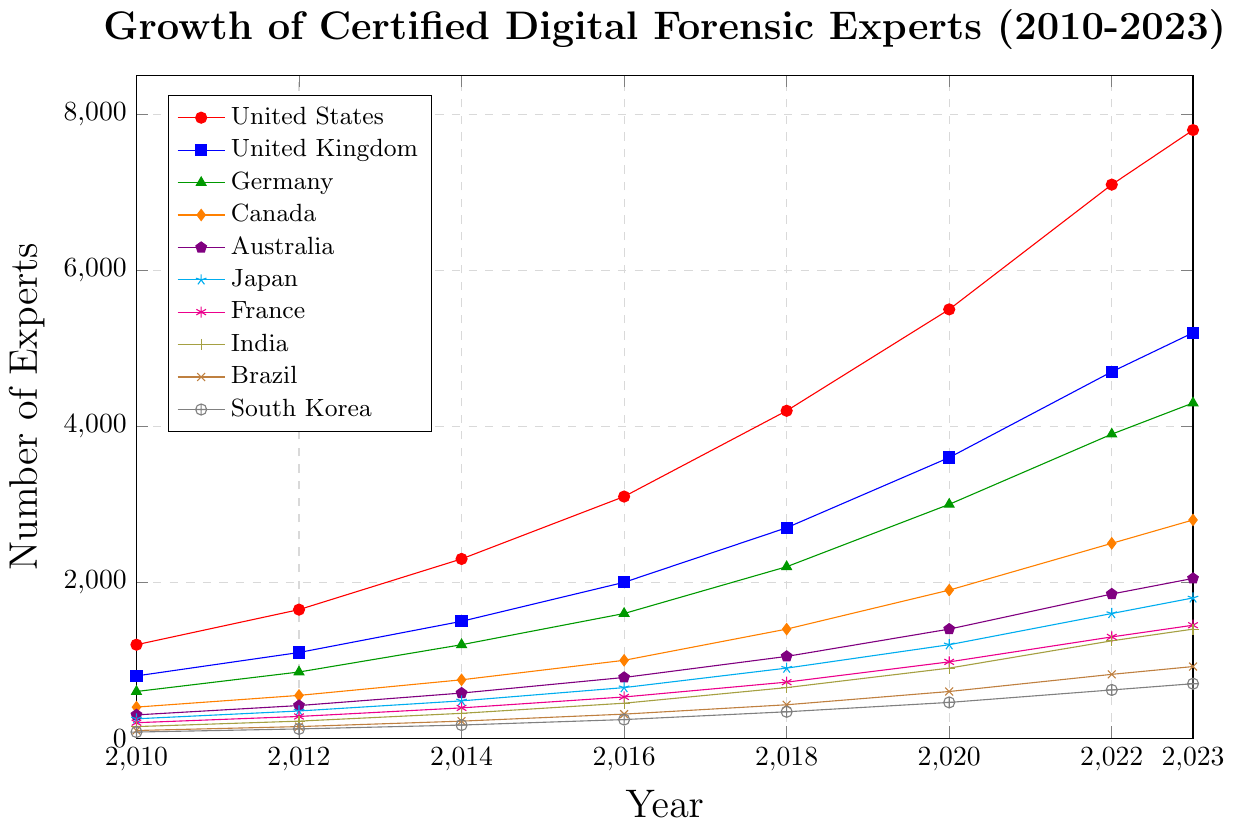Which country had the highest number of certified digital forensic experts in 2023? The United States had the highest number of certified digital forensic experts in 2023. This can be seen by looking at the figure and identifying the highest point on the y-axis for 2023.
Answer: The United States How much did the number of certified digital forensic experts increase in the United Kingdom from 2010 to 2023? The initial value in 2010 for the United Kingdom was 800, and the final value in 2023 was 5200. The increase is calculated as the difference: 5200 - 800 = 4400.
Answer: 4400 Which country saw the smallest increase in the number of certified digital forensic experts between 2010 and 2023? We subtract the 2010 values from the 2023 values for all countries. South Korea has the smallest increase. For South Korea, 2023 value is 700 and 2010 value is 80, so the increase is 700 - 80 = 620.
Answer: South Korea In which year did Germany first exceed 2000 certified digital forensic experts? By examining the data points for Germany in the figure, Germany exceeded 2000 experts in 2020, where it reached 3000 experts.
Answer: 2020 By how much did the number of certified digital forensic experts in India change from 2012 to 2020? The number in 2012 was 220 and in 2020 it was 900. The change is calculated as 900 - 220 = 680.
Answer: 680 Compare the growth trends of Canada and Australia. Over the years, which country had a higher average annual increase in the number of certified digital forensic experts? We calculate the total increase from 2010 to 2023 for both countries and divide by the number of years (13). For Canada: increase = 2800 - 400 = 2400, average annual increase = 2400 / 13 ≈ 184.62. For Australia: increase = 2050 - 300 = 1750, average annual increase = 1750 / 13 ≈ 134.62. Canada had a higher average annual increase.
Answer: Canada Which year saw the largest increase in the number of certified digital forensic experts in the United States? We look at each year-to-year difference for the United States. The largest increase occurred between 2020 and 2022: 7100 - 5500 = 1600.
Answer: Between 2020 and 2022 What was the combined total number of certified digital forensic experts in Japan and Brazil in 2023? The number of experts in Japan in 2023 was 1800 and in Brazil, it was 920. The combined total is 1800 + 920 = 2720.
Answer: 2720 Identify the country with the steepest growth trajectory from 2018 to 2020. By briefly checking the slopes between 2018 and 2020 for all countries, the United States saw the steepest growth, from 4200 to 5500, an increase of 1300. This is greater than any other country in that segment.
Answer: The United States In which year did France first surpass the 1000 certified digital forensic experts mark? The figure shows the progression of France, and it first surpassed 1000 experts in 2020 (980 in 2020 and then 1300 in 2022).
Answer: 2022 